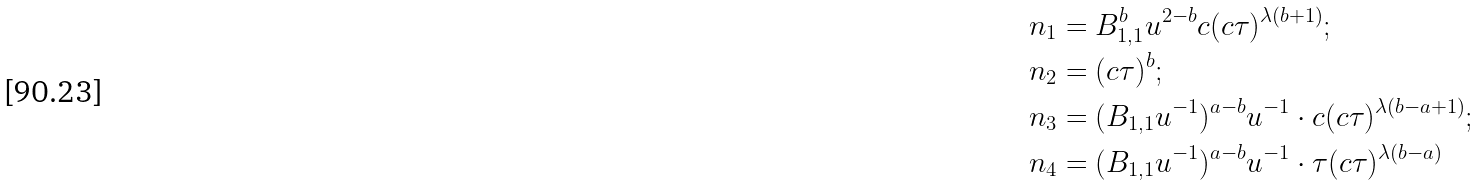<formula> <loc_0><loc_0><loc_500><loc_500>& n _ { 1 } = B _ { 1 , 1 } ^ { b } u ^ { 2 - b } c ( c \tau ) ^ { \lambda ( b + 1 ) } ; \\ & n _ { 2 } = ( c \tau ) ^ { b } ; \\ & n _ { 3 } = ( B _ { 1 , 1 } u ^ { - 1 } ) ^ { a - b } u ^ { - 1 } \cdot c ( c \tau ) ^ { \lambda ( b - a + 1 ) } ; \\ & n _ { 4 } = ( B _ { 1 , 1 } u ^ { - 1 } ) ^ { a - b } u ^ { - 1 } \cdot \tau ( c \tau ) ^ { \lambda ( b - a ) }</formula> 